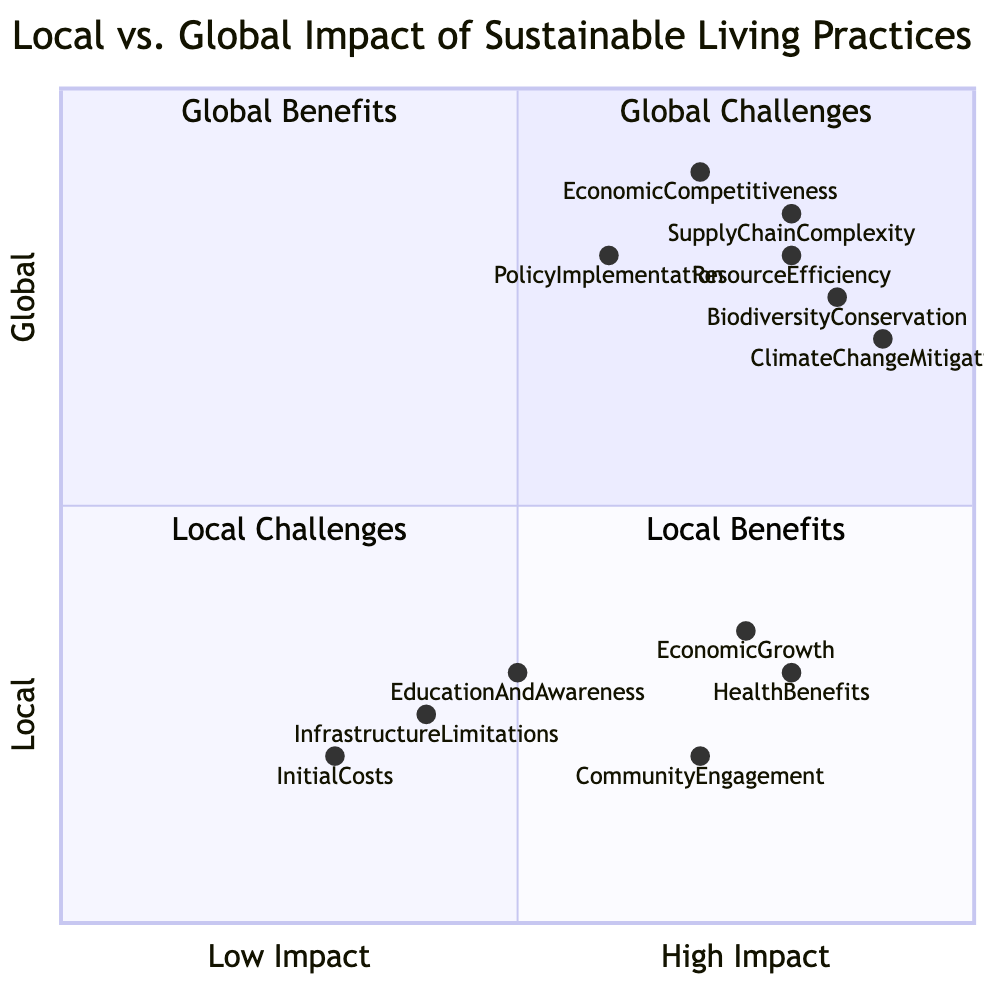What is the quadrant for Climate Change Mitigation? Climate Change Mitigation is located in quadrant 2, which represents Global Benefits because it focuses on a global perspective that contributes positively to sustainability.
Answer: Quadrant 2 How many nodes are in the Local Benefits quadrant? The Local Benefits quadrant (quadrant 4) has three nodes: Community Engagement, Health Benefits, and Economic Growth.
Answer: Three Which has a higher impact, Economic Competitiveness or Initial Costs? Economic Competitiveness is located at [0.7, 0.9] with a high impact rating compared to Initial Costs at [0.3, 0.2]. The coordinates show that Economic Competitiveness has a higher overall impact.
Answer: Economic Competitiveness What type of challenge does Infrastructure Limitations represent? Infrastructure Limitations represents a Local Challenge because it is positioned in quadrant 3, which deals with local sustainable living challenges.
Answer: Local Challenge Which global benefit has the highest impact value? Climate Change Mitigation has the highest overall impact value at [0.9, 0.7], appearing in quadrant 2.
Answer: 0.9 Which quadrant has the most nodes? Quadrant 3 (Local Challenges) contains three nodes, which is the same as Quadrant 4 (Local Benefits). All other quadrants contain fewer nodes.
Answer: Quadrant 3 What is the impact level range of Supply Chain Complexity? Supply Chain Complexity has an impact level of 0.8 for its x-axis rating, situated high in the global challenge box indicating a significant complexity.
Answer: 0.8 In which quadrant do Health Benefits fall? Health Benefits falls into quadrant 4, identified as Local Benefits, focusing on the local positive effects of sustainable practices.
Answer: Quadrant 4 What node has the lowest impact on the global scale? The node with the lowest impact on the global scale is Initial Costs, located at [0.3, 0.2].
Answer: Initial Costs 